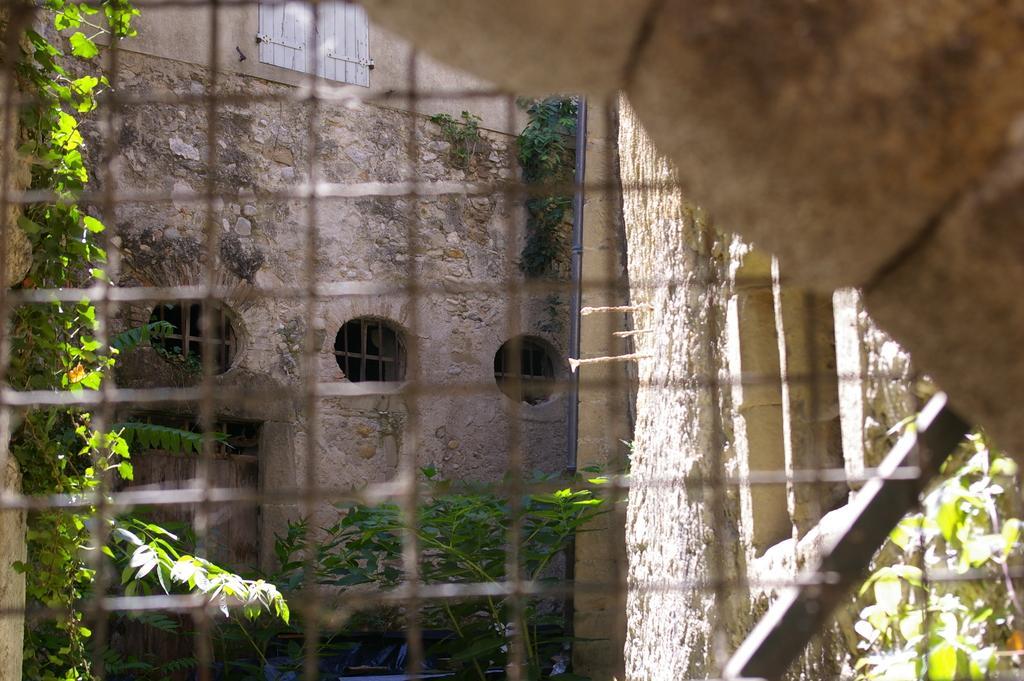Could you give a brief overview of what you see in this image? This is a welded mesh wire and on the right side at the top corner we can see the wall. In the background we can see wall, windows, plants, door and a pole. 